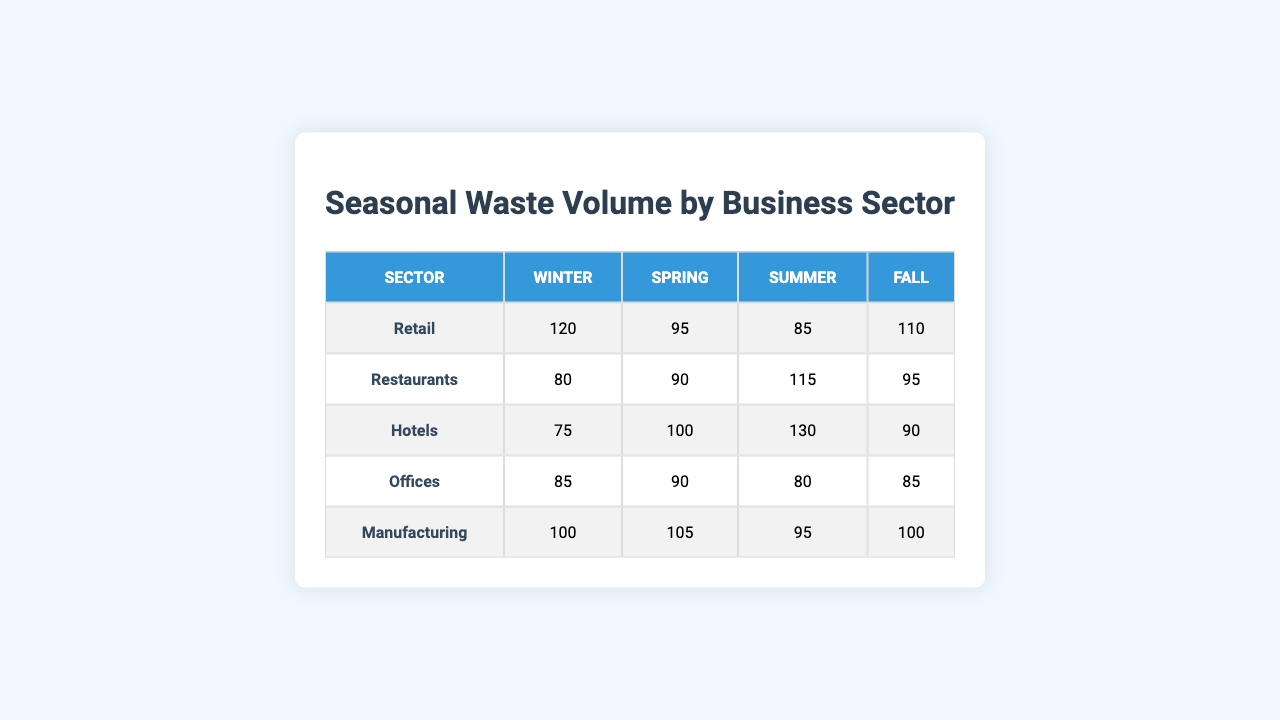What is the waste volume for Restaurants in Summer? The table shows that the waste volume for Restaurants in the Summer season is 115.
Answer: 115 Which sector produced the least amount of waste in Winter? By comparing the waste volumes in Winter, Hotels has the smallest volume at 75.
Answer: Hotels What is the total waste volume for Offices across all seasons? The waste volumes for Offices in all seasons are: Winter (85) + Spring (90) + Summer (80) + Fall (85). The total is 85 + 90 + 80 + 85 = 340.
Answer: 340 Is the waste volume for Hotels higher in Summer than in Spring? In Summer, Hotels produced 130, while in Spring it was 100. Since 130 > 100, this statement is true.
Answer: Yes What season had the highest total waste volume across all sectors? Calculating the total waste volume for each season: Winter (120+80+75+85+100=460), Spring (95+90+100+90+105=480), Summer (85+115+130+80+95=505), Fall (110+95+90+85+100=480). Summer has the highest total volume of 505.
Answer: Summer Which business sector showed an increase in waste volume from Winter to Spring? By comparing Winter and Spring waste volumes for each sector, Restaurants (80 to 90) and Manufacturing (100 to 105) both show an increase.
Answer: Restaurants & Manufacturing What is the average waste volume for the Retail sector across all seasons? The seasons for Retail have waste volumes of Winter (120), Spring (95), Summer (85), and Fall (110). The average is calculated as (120 + 95 + 85 + 110) / 4 = 102.5.
Answer: 102.5 Which sector has the most consistent waste volume throughout the seasons? Assessing the differences in waste volumes per season for each sector, Offices has values that fluctuate minimally (85, 90, 80, 85) with only a maximum difference of 10.
Answer: Offices Which sector in Fall had the same waste volume as in Winter? By examining the waste volumes in Fall and Winter, we see that Manufacturing had 100 in both seasons.
Answer: Manufacturing Does the total waste volume for Restaurants in Spring and Fall exceed that of Hotels in Summer? Restaurants waste volume in Spring is 90 and in Fall is 95, totaling 185. Hotels waste volume in Summer is 130. Since 185 > 130, this is true.
Answer: Yes 